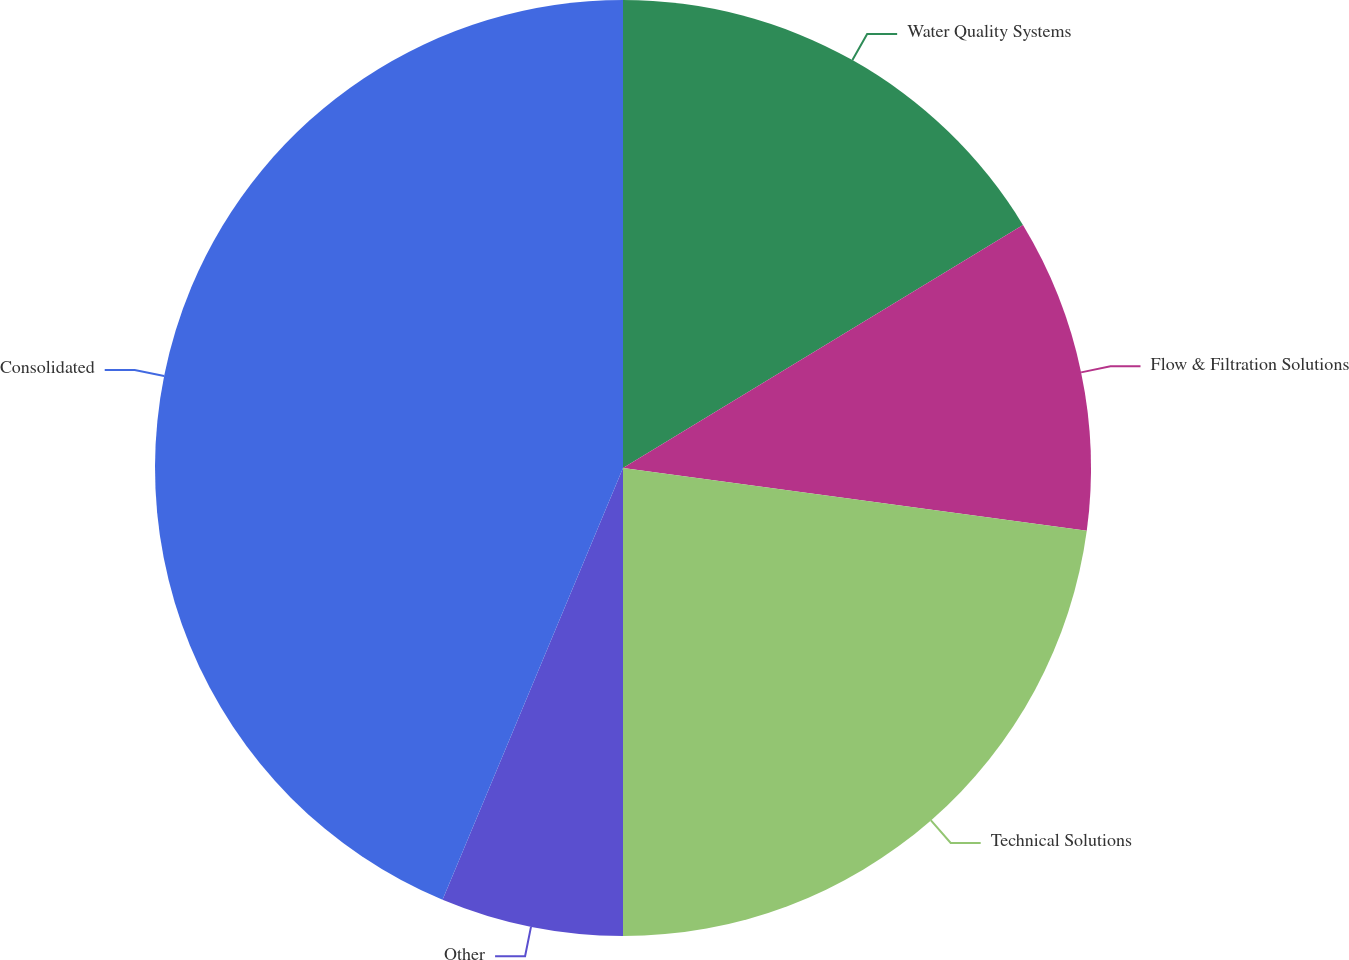Convert chart to OTSL. <chart><loc_0><loc_0><loc_500><loc_500><pie_chart><fcel>Water Quality Systems<fcel>Flow & Filtration Solutions<fcel>Technical Solutions<fcel>Other<fcel>Consolidated<nl><fcel>16.31%<fcel>10.83%<fcel>22.86%<fcel>6.3%<fcel>43.7%<nl></chart> 